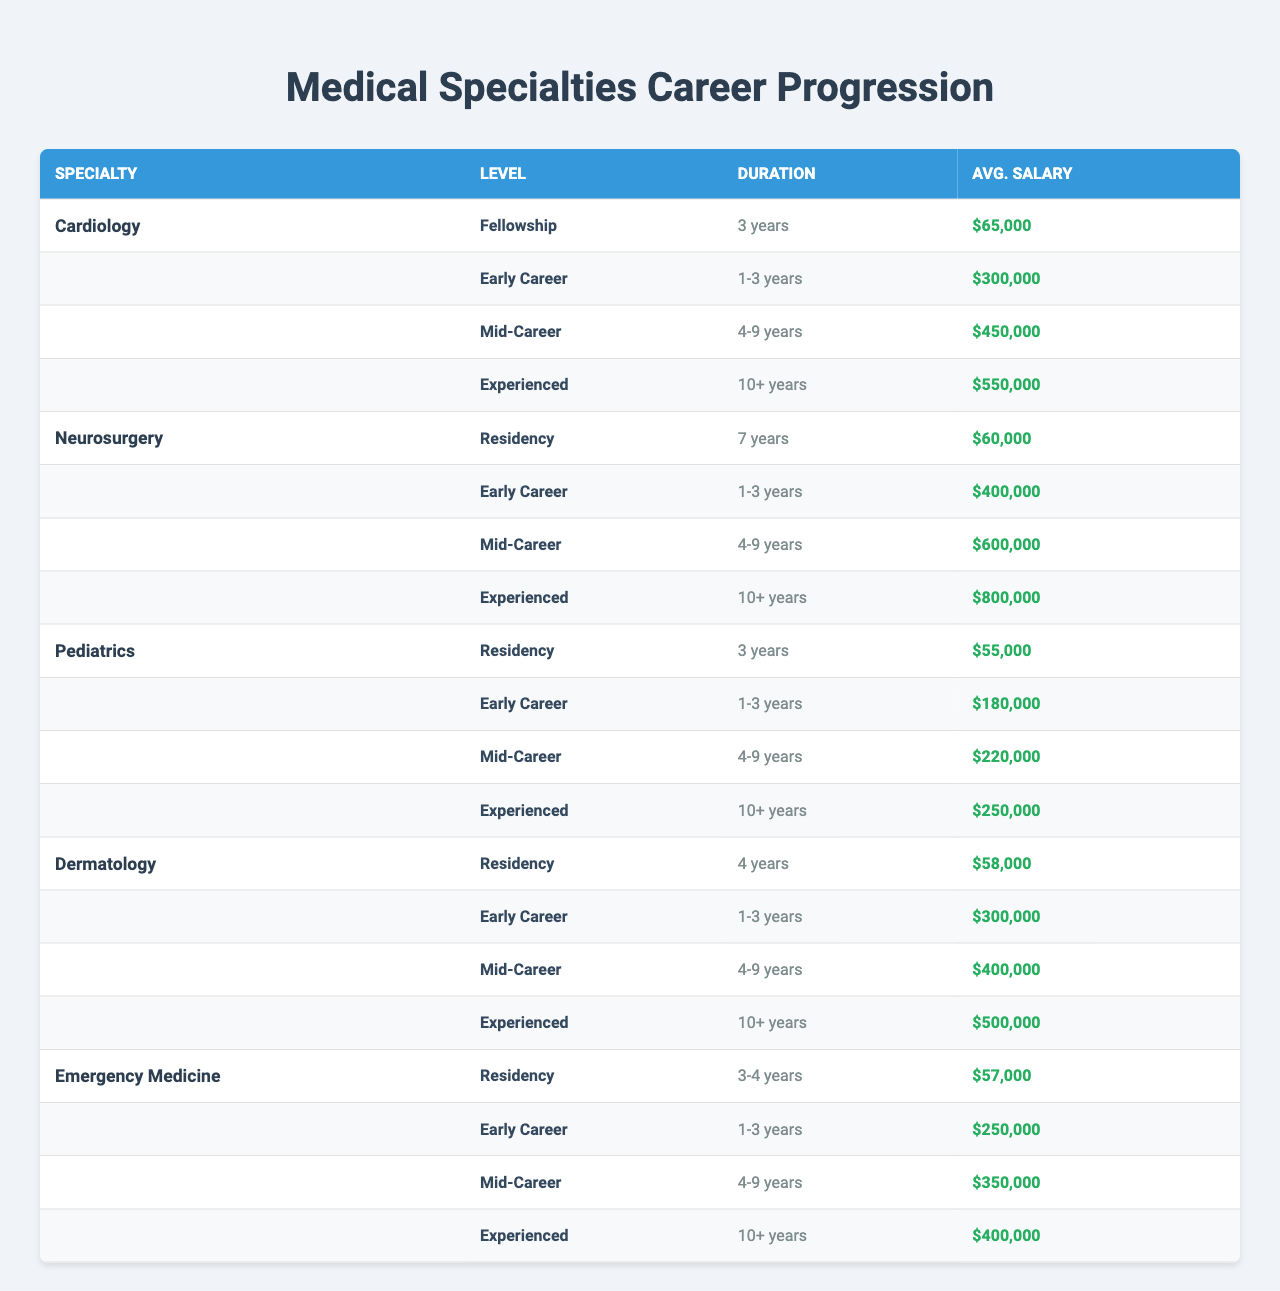What is the average salary for an experienced cardiologist? The average salary for an experienced cardiologist, according to the table, is $550,000.
Answer: $550,000 What is the duration of residency for pediatrics? The table states that the residency duration for pediatrics is 3 years.
Answer: 3 years True or False: The average salary for a mid-career neurosurgeon is higher than that of an early-career cardiologist. The average salary for a mid-career neurosurgeon is $600,000 and for an early-career cardiologist it is $300,000. Since $600,000 is greater than $300,000, the statement is True.
Answer: True Which specialty has the highest average salary for early career professionals? By comparing early career salaries, neurosurgery has the highest at $400,000, compared to cardiology ($300,000), dermatology ($300,000), pediatrics ($180,000), and emergency medicine ($250,000).
Answer: Neurosurgery What is the difference in average salary between mid-career dermatologists and experienced emergency medicine physicians? The average salary for mid-career dermatologists is $400,000 and for experienced emergency medicine physicians is $400,000. The difference is $400,000 - $400,000 = $0.
Answer: $0 How long do cardiologists typically spend in fellowship? The table shows that cardiologists spend 3 years in fellowship.
Answer: 3 years Which specialty's early career salary is closest to $250,000? Emergency medicine has an early career salary of $250,000, which matches the target amount.
Answer: Emergency Medicine What is the average salary increase from early career to mid-career for dermatology? The early career salary for dermatology is $300,000 and the mid-career salary is $400,000. The increase is $400,000 - $300,000 = $100,000.
Answer: $100,000 List the specialties that have a residency duration longer than 3 years. The specialties with longer residency durations are neurosurgery (7 years) and dermatology (4 years).
Answer: Neurosurgery, Dermatology How much does the average salary for an experienced pediatrician differ from that of an early career pediatrician? The average salary for an experienced pediatrician is $250,000 and for an early career pediatrician is $180,000. The difference is $250,000 - $180,000 = $70,000.
Answer: $70,000 